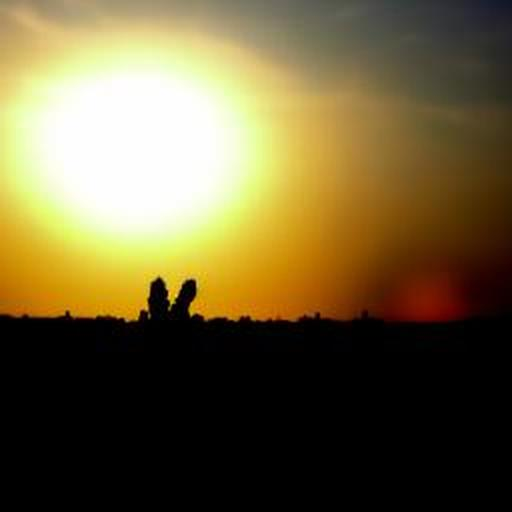What time of day does this image depict? The image captures a scene around sunset, characterized by the warm hues in the sky and the sun's position near the horizon. 